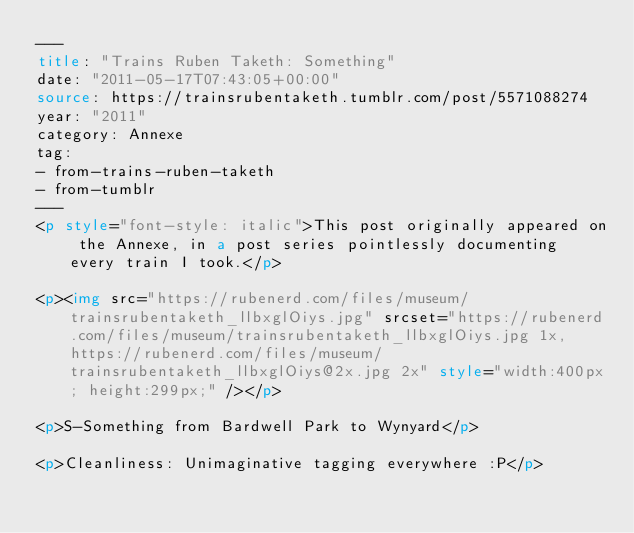Convert code to text. <code><loc_0><loc_0><loc_500><loc_500><_HTML_>---
title: "Trains Ruben Taketh: Something"
date: "2011-05-17T07:43:05+00:00"
source: https://trainsrubentaketh.tumblr.com/post/5571088274
year: "2011"
category: Annexe
tag: 
- from-trains-ruben-taketh
- from-tumblr
---
<p style="font-style: italic">This post originally appeared on the Annexe, in a post series pointlessly documenting every train I took.</p>

<p><img src="https://rubenerd.com/files/museum/trainsrubentaketh_llbxglOiys.jpg" srcset="https://rubenerd.com/files/museum/trainsrubentaketh_llbxglOiys.jpg 1x, https://rubenerd.com/files/museum/trainsrubentaketh_llbxglOiys@2x.jpg 2x" style="width:400px; height:299px;" /></p>

<p>S-Something from Bardwell Park to Wynyard</p>

<p>Cleanliness: Unimaginative tagging everywhere :P</p>
</code> 